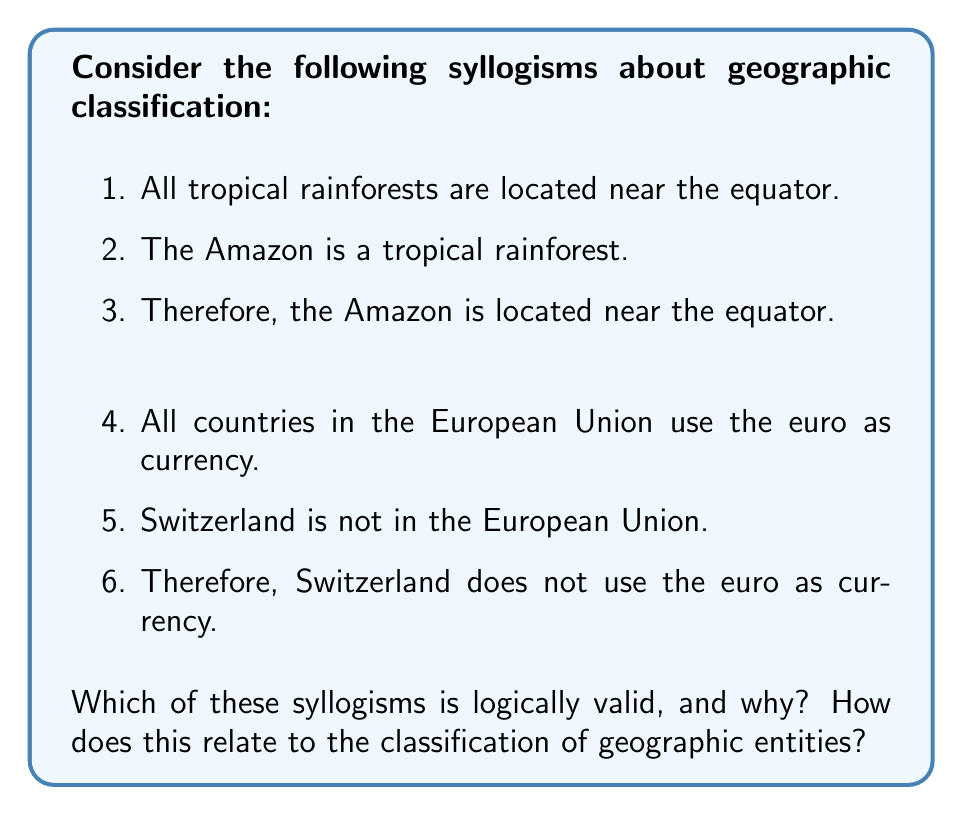Show me your answer to this math problem. To analyze the logical structure of these geographic classification syllogisms, we need to examine their forms and validity:

1. Syllogism about the Amazon:
   Let P: tropical rainforests
   Let Q: located near the equator
   Let R: the Amazon

   The syllogism can be written as:
   $$\begin{align}
   &\text{All P are Q}\\
   &\text{R is P}\\
   &\therefore \text{R is Q}
   \end{align}$$

   This follows the valid syllogistic form known as "Barbara":
   $$\begin{align}
   &\text{All M are P}\\
   &\text{S is M}\\
   &\therefore \text{S is P}
   \end{align}$$

   Therefore, this syllogism is logically valid.

2. Syllogism about Switzerland:
   Let P: countries in the European Union
   Let Q: use the euro as currency
   Let R: Switzerland

   The syllogism can be written as:
   $$\begin{align}
   &\text{All P are Q}\\
   &\text{R is not P}\\
   &\therefore \text{R is not Q}
   \end{align}$$

   This does not follow a valid syllogistic form. The conclusion does not necessarily follow from the premises. This is known as the fallacy of denying the antecedent:
   $$\begin{align}
   &\text{If P, then Q}\\
   &\text{Not P}\\
   &\therefore \text{Not Q}
   \end{align}$$

   Therefore, this syllogism is not logically valid.

In terms of geographic classification, the first syllogism demonstrates a valid way to classify entities based on their properties. If we know that all members of a class have a certain property, and an entity belongs to that class, we can correctly infer that the entity has that property.

The second syllogism, however, shows a potential pitfall in geographic classification. Just because an entity doesn't belong to a certain class doesn't mean it lacks all properties associated with that class. In this case, while Switzerland isn't in the EU, it doesn't necessarily mean it doesn't use the euro (although in reality, it doesn't).

This analysis highlights the importance of careful logical reasoning when creating or using geographic classification systems, to avoid making incorrect inferences about the properties of geographic entities.
Answer: The first syllogism about the Amazon is logically valid, while the second syllogism about Switzerland is not logically valid. This demonstrates that in geographic classification, we can make valid inferences about an entity's properties based on its class membership, but we cannot always make valid inferences about an entity's properties based on its non-membership in a class. 